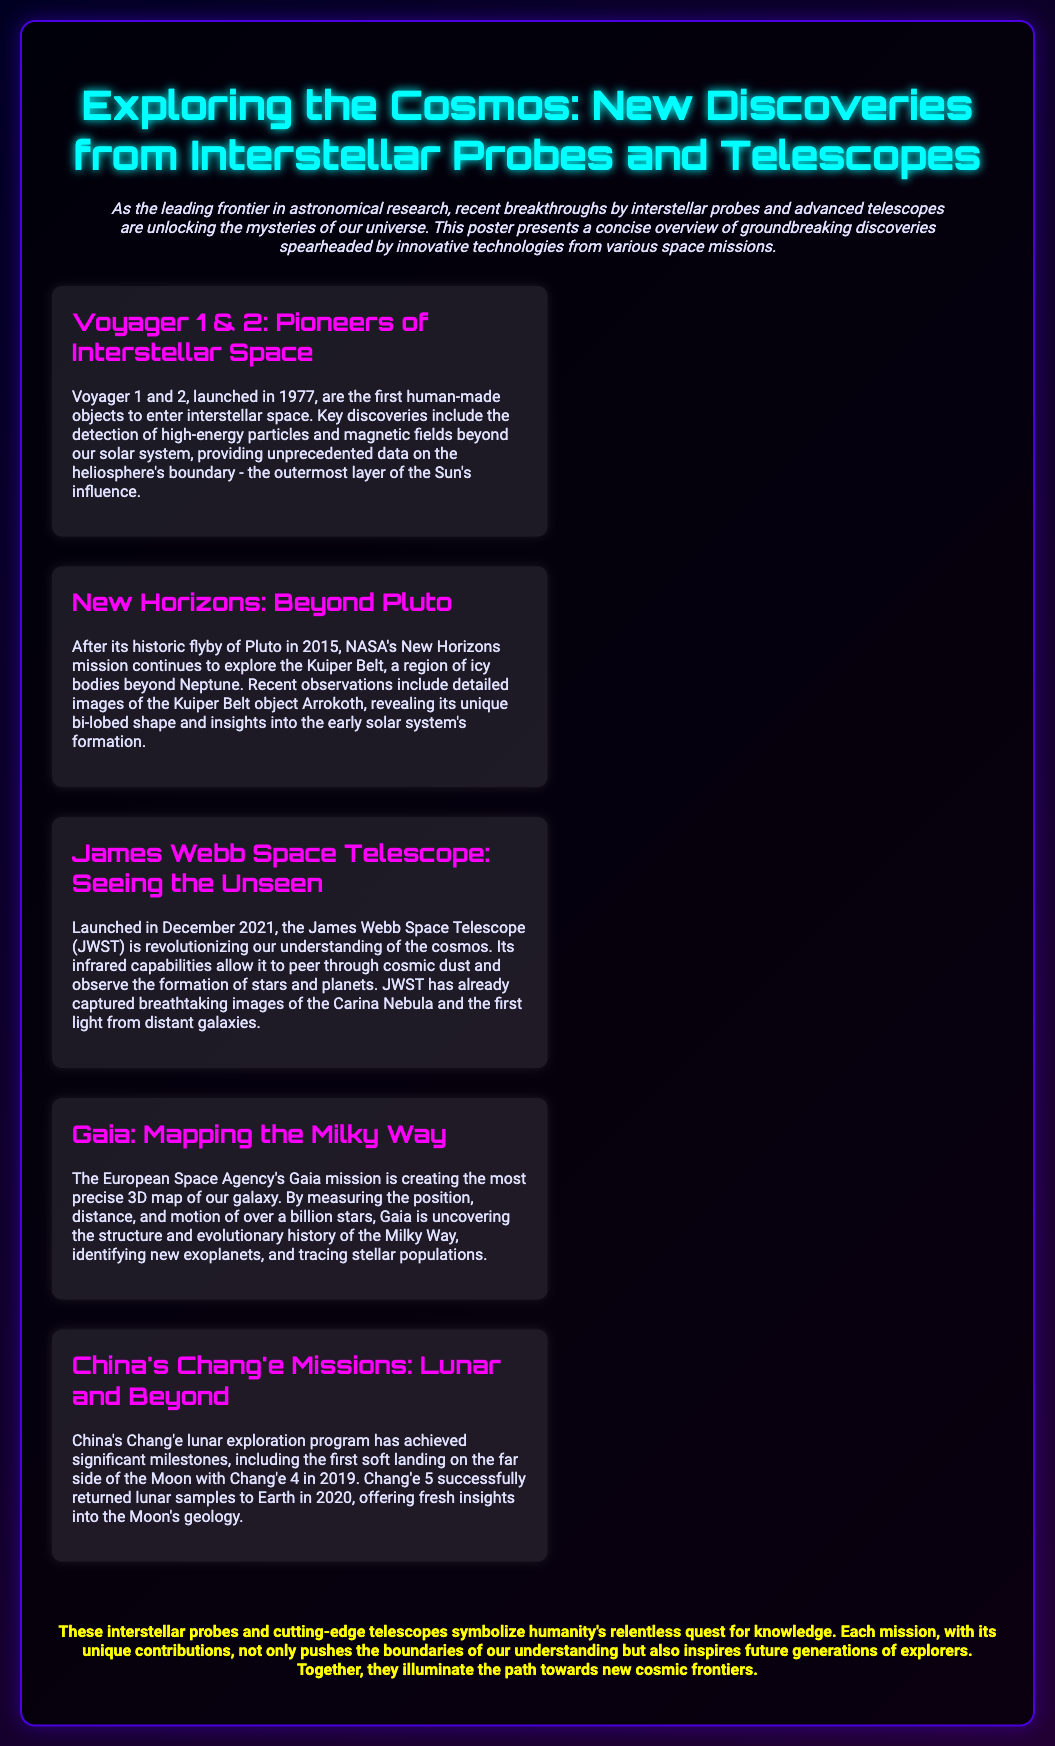What are the names of the two interstellar probes mentioned? The document lists Voyager 1 and Voyager 2 as the two interstellar probes.
Answer: Voyager 1 and 2 What year was the James Webb Space Telescope launched? The launch date for the James Webb Space Telescope is mentioned in the document as December 2021.
Answer: December 2021 What unique shape was revealed about the Kuiper Belt object Arrokoth? The text states that Arrokoth has a unique bi-lobed shape, indicating its specific morphology.
Answer: Bi-lobed shape Which mission successfully returned lunar samples to Earth? The document indicates that Chang'e 5 was the mission that accomplished the return of lunar samples.
Answer: Chang'e 5 How many stars is the Gaia mission measuring? The number of stars that the Gaia mission is measuring is over a billion, reflecting the scale of the project.
Answer: Over a billion What significant accomplishment did Chang'e 4 achieve in 2019? The document specifies that Chang'e 4 achieved the first soft landing on the far side of the Moon in 2019.
Answer: First soft landing on the far side of the Moon What region is NASA's New Horizons mission exploring? The text indicates that New Horizons is exploring the Kuiper Belt, a specific area beyond Neptune.
Answer: Kuiper Belt What distinctive feature does the James Webb Space Telescope possess? The document highlights that the JWST has infrared capabilities, which is a key feature that sets it apart.
Answer: Infrared capabilities 